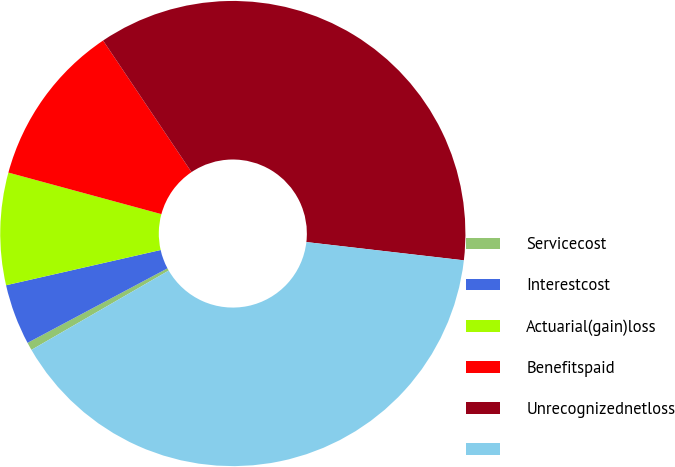<chart> <loc_0><loc_0><loc_500><loc_500><pie_chart><fcel>Servicecost<fcel>Interestcost<fcel>Actuarial(gain)loss<fcel>Benefitspaid<fcel>Unrecognizednetloss<fcel>Unnamed: 5<nl><fcel>0.55%<fcel>4.22%<fcel>7.79%<fcel>11.36%<fcel>36.26%<fcel>39.83%<nl></chart> 